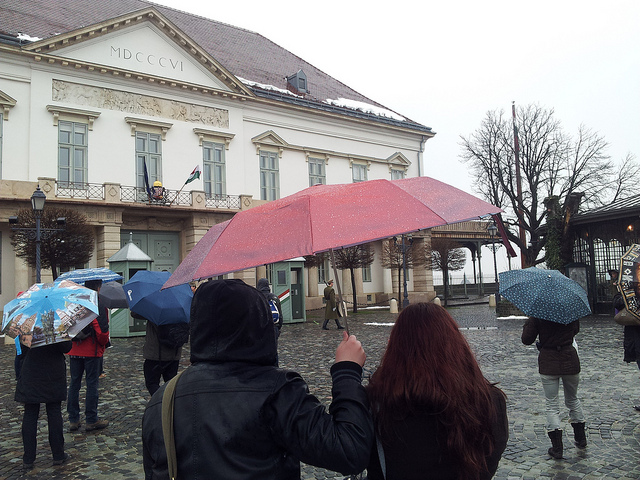Identify and read out the text in this image. MDCCCVI P 